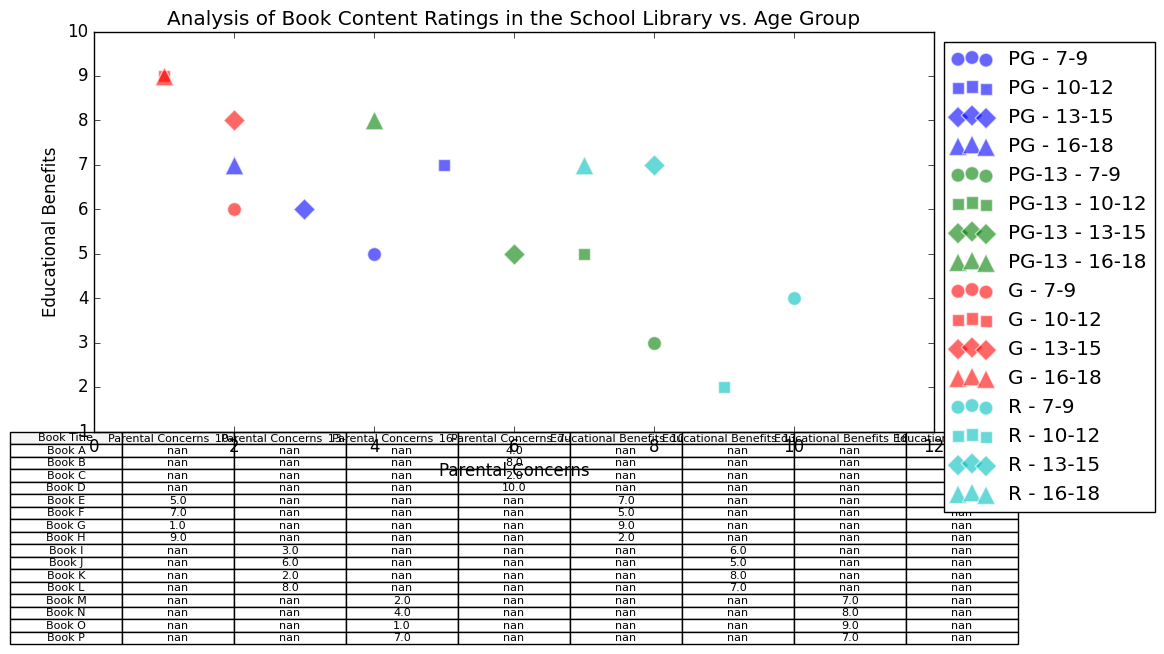What is the average parental concern rating for PG-13 books across all age groups? Average the parental concerns for PG-13 books from the table (Book B, Book F, Book J, Book N): (8 + 7 + 6 + 4) / 4 = 25 / 4 = 6.25
Answer: 6.25 Which age group has the highest average educational benefits rating for G-rated books? Compare the educational benefits for G-rated books in each age group: 7-9 (Book C: 6), 10-12 (Book G: 9), 13-15 (Book K: 8), 16-18 (Book O: 9). The highest average is for the 10-12 and 16-18 age groups, both 9.
Answer: 10-12 and 16-18 For the age group 10-12, which content rating has the lowest parental concern? From the 10-12 age group in the chart (PG: Book E - 5, PG-13: Book F - 7, G: Book G - 1, R: Book H - 9), G-rated books have the lowest parental concern.
Answer: G How do the educational benefits of R-rated books for ages 13-15 compare to those for ages 16-18? R-rated books for ages 13-15 (Book L: 7) and 16-18 (Book P: 7) both have an educational benefits rating of 7.
Answer: Equal What is the difference in parental concerns between PG-rated books for ages 7-9 and 16-18? Parental concerns for PG-rated books: 7-9 (Book A: 4), 16-18 (Book M: 2). The difference is 4 - 2 = 2.
Answer: 2 Which book has the highest educational benefit rating for ages 7-9? Compare educational benefits for ages 7-9: Book A (5), Book B (3), Book C (6), Book D (4). Book C has the highest rating.
Answer: Book C Are parental concerns higher for Fiction or Non-Fiction books in the age group 13-15? Compute average parental concerns for 13-15 age Fiction (Book I: 3 + Book J: 6 = 9/2 = 4.5) vs. Non-Fiction (Book K: 2 + Book L: 8 = 10/2 = 5). Parental concerns are higher for Non-Fiction.
Answer: Non-Fiction What is the visual marker used for G-rated books in the chart? From the color and marker choices in the chart, G-rated books are denoted with 'g' (green) color and circle (o) marker.
Answer: Circle (Green) What is the range of educational benefits ratings for PG-13 books across all age groups? Educational benefits ratings for PG-13 books are: Book B (3), Book F (5), Book J (5), Book N (8). The range is the difference between highest and lowest values: 8 - 3 = 5.
Answer: 5 